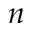<formula> <loc_0><loc_0><loc_500><loc_500>n</formula> 